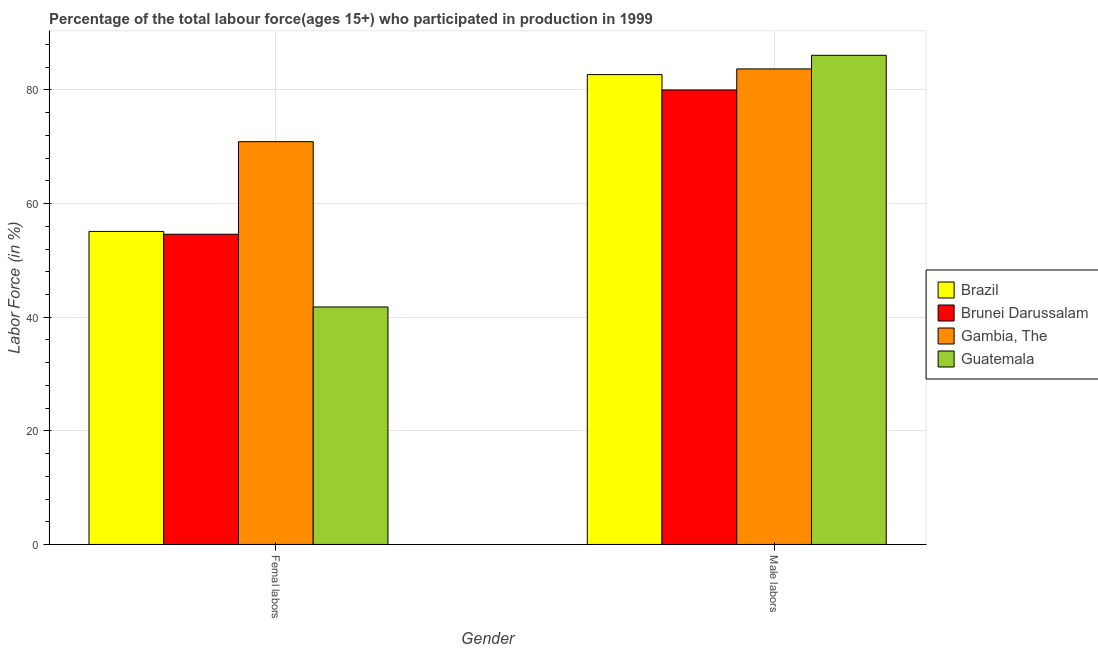Are the number of bars on each tick of the X-axis equal?
Your answer should be compact. Yes. How many bars are there on the 1st tick from the left?
Offer a very short reply. 4. What is the label of the 2nd group of bars from the left?
Your response must be concise. Male labors. What is the percentage of female labor force in Gambia, The?
Keep it short and to the point. 70.9. Across all countries, what is the maximum percentage of male labour force?
Give a very brief answer. 86.1. Across all countries, what is the minimum percentage of male labour force?
Your response must be concise. 80. In which country was the percentage of male labour force maximum?
Your answer should be compact. Guatemala. In which country was the percentage of male labour force minimum?
Provide a short and direct response. Brunei Darussalam. What is the total percentage of female labor force in the graph?
Your answer should be very brief. 222.4. What is the difference between the percentage of male labour force in Brunei Darussalam and that in Brazil?
Your answer should be very brief. -2.7. What is the difference between the percentage of male labour force in Brunei Darussalam and the percentage of female labor force in Guatemala?
Your answer should be compact. 38.2. What is the average percentage of female labor force per country?
Give a very brief answer. 55.6. What is the difference between the percentage of female labor force and percentage of male labour force in Guatemala?
Offer a very short reply. -44.3. In how many countries, is the percentage of male labour force greater than 80 %?
Your answer should be very brief. 3. What is the ratio of the percentage of male labour force in Gambia, The to that in Guatemala?
Make the answer very short. 0.97. Is the percentage of male labour force in Gambia, The less than that in Brazil?
Give a very brief answer. No. What does the 1st bar from the left in Femal labors represents?
Make the answer very short. Brazil. How many bars are there?
Offer a terse response. 8. What is the difference between two consecutive major ticks on the Y-axis?
Provide a short and direct response. 20. Are the values on the major ticks of Y-axis written in scientific E-notation?
Provide a succinct answer. No. Does the graph contain any zero values?
Give a very brief answer. No. How many legend labels are there?
Make the answer very short. 4. What is the title of the graph?
Your answer should be very brief. Percentage of the total labour force(ages 15+) who participated in production in 1999. Does "Sweden" appear as one of the legend labels in the graph?
Ensure brevity in your answer.  No. What is the label or title of the X-axis?
Your response must be concise. Gender. What is the Labor Force (in %) of Brazil in Femal labors?
Provide a succinct answer. 55.1. What is the Labor Force (in %) in Brunei Darussalam in Femal labors?
Your answer should be compact. 54.6. What is the Labor Force (in %) of Gambia, The in Femal labors?
Make the answer very short. 70.9. What is the Labor Force (in %) in Guatemala in Femal labors?
Provide a succinct answer. 41.8. What is the Labor Force (in %) of Brazil in Male labors?
Your answer should be compact. 82.7. What is the Labor Force (in %) of Brunei Darussalam in Male labors?
Keep it short and to the point. 80. What is the Labor Force (in %) in Gambia, The in Male labors?
Give a very brief answer. 83.7. What is the Labor Force (in %) in Guatemala in Male labors?
Your response must be concise. 86.1. Across all Gender, what is the maximum Labor Force (in %) in Brazil?
Offer a very short reply. 82.7. Across all Gender, what is the maximum Labor Force (in %) in Brunei Darussalam?
Give a very brief answer. 80. Across all Gender, what is the maximum Labor Force (in %) of Gambia, The?
Your response must be concise. 83.7. Across all Gender, what is the maximum Labor Force (in %) in Guatemala?
Your answer should be very brief. 86.1. Across all Gender, what is the minimum Labor Force (in %) of Brazil?
Your response must be concise. 55.1. Across all Gender, what is the minimum Labor Force (in %) in Brunei Darussalam?
Ensure brevity in your answer.  54.6. Across all Gender, what is the minimum Labor Force (in %) in Gambia, The?
Your response must be concise. 70.9. Across all Gender, what is the minimum Labor Force (in %) of Guatemala?
Offer a very short reply. 41.8. What is the total Labor Force (in %) in Brazil in the graph?
Provide a succinct answer. 137.8. What is the total Labor Force (in %) of Brunei Darussalam in the graph?
Give a very brief answer. 134.6. What is the total Labor Force (in %) in Gambia, The in the graph?
Offer a very short reply. 154.6. What is the total Labor Force (in %) of Guatemala in the graph?
Offer a very short reply. 127.9. What is the difference between the Labor Force (in %) in Brazil in Femal labors and that in Male labors?
Your answer should be compact. -27.6. What is the difference between the Labor Force (in %) in Brunei Darussalam in Femal labors and that in Male labors?
Make the answer very short. -25.4. What is the difference between the Labor Force (in %) of Guatemala in Femal labors and that in Male labors?
Offer a terse response. -44.3. What is the difference between the Labor Force (in %) in Brazil in Femal labors and the Labor Force (in %) in Brunei Darussalam in Male labors?
Make the answer very short. -24.9. What is the difference between the Labor Force (in %) of Brazil in Femal labors and the Labor Force (in %) of Gambia, The in Male labors?
Offer a very short reply. -28.6. What is the difference between the Labor Force (in %) of Brazil in Femal labors and the Labor Force (in %) of Guatemala in Male labors?
Provide a short and direct response. -31. What is the difference between the Labor Force (in %) in Brunei Darussalam in Femal labors and the Labor Force (in %) in Gambia, The in Male labors?
Give a very brief answer. -29.1. What is the difference between the Labor Force (in %) in Brunei Darussalam in Femal labors and the Labor Force (in %) in Guatemala in Male labors?
Your answer should be very brief. -31.5. What is the difference between the Labor Force (in %) in Gambia, The in Femal labors and the Labor Force (in %) in Guatemala in Male labors?
Your response must be concise. -15.2. What is the average Labor Force (in %) in Brazil per Gender?
Offer a terse response. 68.9. What is the average Labor Force (in %) of Brunei Darussalam per Gender?
Offer a terse response. 67.3. What is the average Labor Force (in %) of Gambia, The per Gender?
Provide a short and direct response. 77.3. What is the average Labor Force (in %) in Guatemala per Gender?
Provide a short and direct response. 63.95. What is the difference between the Labor Force (in %) in Brazil and Labor Force (in %) in Gambia, The in Femal labors?
Offer a very short reply. -15.8. What is the difference between the Labor Force (in %) in Brunei Darussalam and Labor Force (in %) in Gambia, The in Femal labors?
Keep it short and to the point. -16.3. What is the difference between the Labor Force (in %) of Brunei Darussalam and Labor Force (in %) of Guatemala in Femal labors?
Ensure brevity in your answer.  12.8. What is the difference between the Labor Force (in %) of Gambia, The and Labor Force (in %) of Guatemala in Femal labors?
Provide a short and direct response. 29.1. What is the difference between the Labor Force (in %) in Brazil and Labor Force (in %) in Brunei Darussalam in Male labors?
Offer a terse response. 2.7. What is the difference between the Labor Force (in %) in Brazil and Labor Force (in %) in Guatemala in Male labors?
Make the answer very short. -3.4. What is the ratio of the Labor Force (in %) in Brazil in Femal labors to that in Male labors?
Offer a terse response. 0.67. What is the ratio of the Labor Force (in %) of Brunei Darussalam in Femal labors to that in Male labors?
Your answer should be compact. 0.68. What is the ratio of the Labor Force (in %) in Gambia, The in Femal labors to that in Male labors?
Keep it short and to the point. 0.85. What is the ratio of the Labor Force (in %) of Guatemala in Femal labors to that in Male labors?
Your answer should be compact. 0.49. What is the difference between the highest and the second highest Labor Force (in %) in Brazil?
Make the answer very short. 27.6. What is the difference between the highest and the second highest Labor Force (in %) in Brunei Darussalam?
Ensure brevity in your answer.  25.4. What is the difference between the highest and the second highest Labor Force (in %) of Guatemala?
Keep it short and to the point. 44.3. What is the difference between the highest and the lowest Labor Force (in %) in Brazil?
Offer a very short reply. 27.6. What is the difference between the highest and the lowest Labor Force (in %) of Brunei Darussalam?
Provide a short and direct response. 25.4. What is the difference between the highest and the lowest Labor Force (in %) in Gambia, The?
Provide a short and direct response. 12.8. What is the difference between the highest and the lowest Labor Force (in %) of Guatemala?
Give a very brief answer. 44.3. 